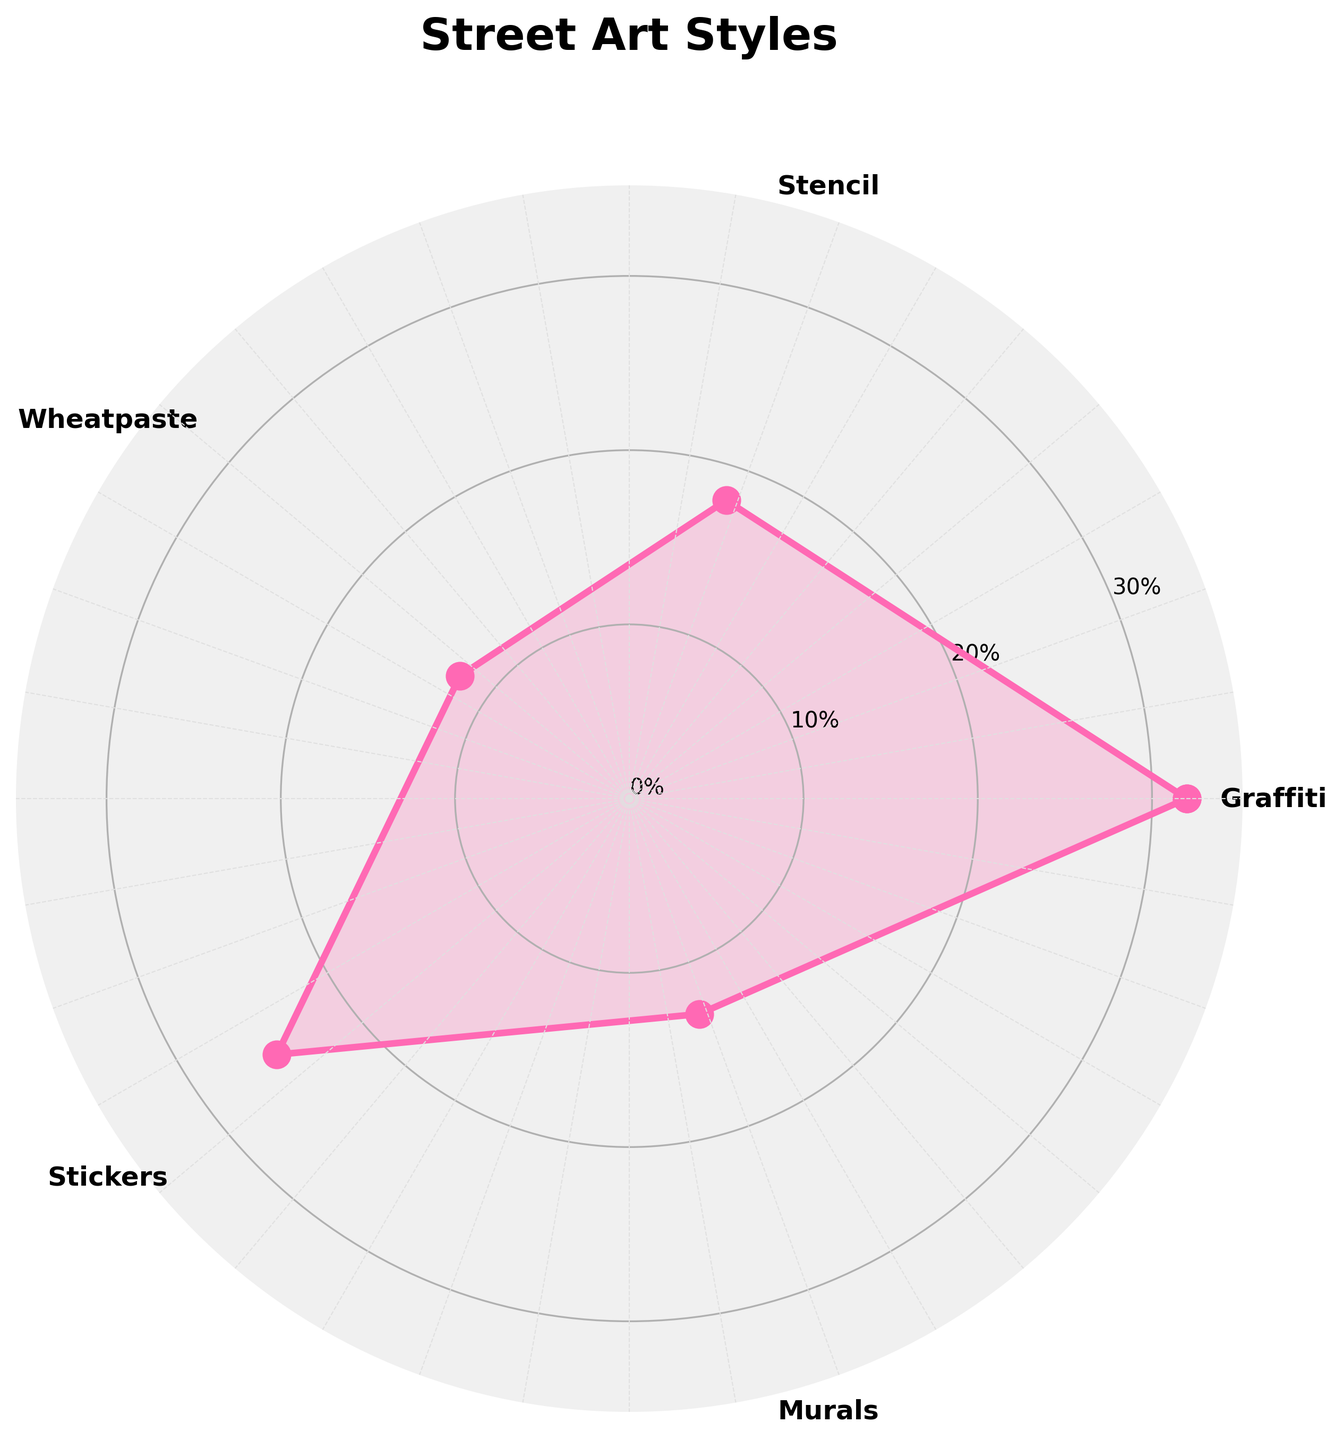what is the proportion of graffiti in street art? Look at the polar chart and find the section labeled "Graffiti." Based on the radial distance from the center, the proportion noted at that point is 32%.
Answer: 32% How many different street art styles are shown in the chart? Identify the unique labels around the circumference of the polar chart. There are five distinct styles listed.
Answer: 5 What is the proportion of styles that fall under 20%? Identify the proportions for each style and select those under 20%. The styles are Stencil (18%), Wheatpaste (12%), and Murals (13%).
Answer: 3 Which street art style has the second highest proportion? Review the proportions and sort them in descending order. The second highest is Stickers with 25%.
Answer: Stickers What is the combined proportion of Stencil and Wheatpaste? Add the proportions of Stencil (18%) and Wheatpaste (12%). 18 + 12 = 30%
Answer: 30% How much greater is the proportion of Graffiti compared to Murals? Subtract the proportion of Murals (13%) from Graffiti (32%). 32 - 13 = 19%
Answer: 19% which street art styles are shown above the 10% mark on the y-axis? Check the radial distances that exceed the 10% mark. Graffiti, Stencil, Wheatpaste, Stickers, and Murals all exceed this mark.
Answer: 5 styles Which street art style is displayed at the smallest angle on the chart? The first angle in a polar chart corresponds to Graffiti, as it is the first label around the circle.
Answer: Graffiti What is the average proportion of all the art techniques shown in the chart? Sum the proportions (32 + 18 + 12 + 25 + 13 = 100) and divide by the number of styles (5). 100 / 5 = 20%
Answer: 20% How does the proportion of Stickers compare to the average proportion of all styles? Calculate the average (20%) and note that Stickers' proportion is 25%. Stickers (25%) is greater than the average (20%).
Answer: Greater than 